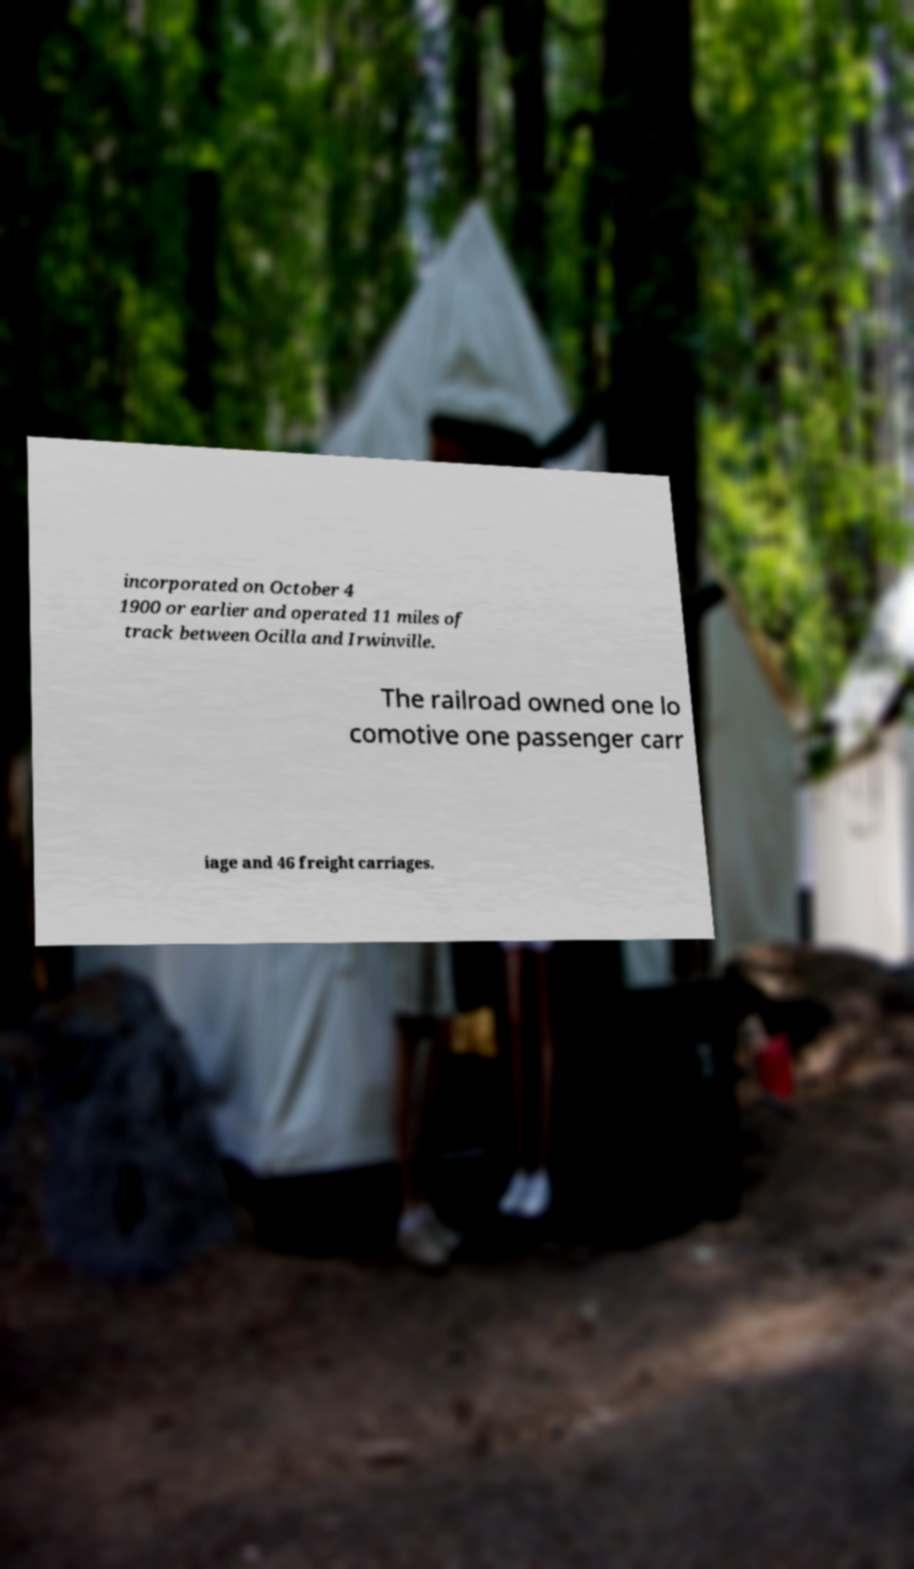Could you extract and type out the text from this image? incorporated on October 4 1900 or earlier and operated 11 miles of track between Ocilla and Irwinville. The railroad owned one lo comotive one passenger carr iage and 46 freight carriages. 